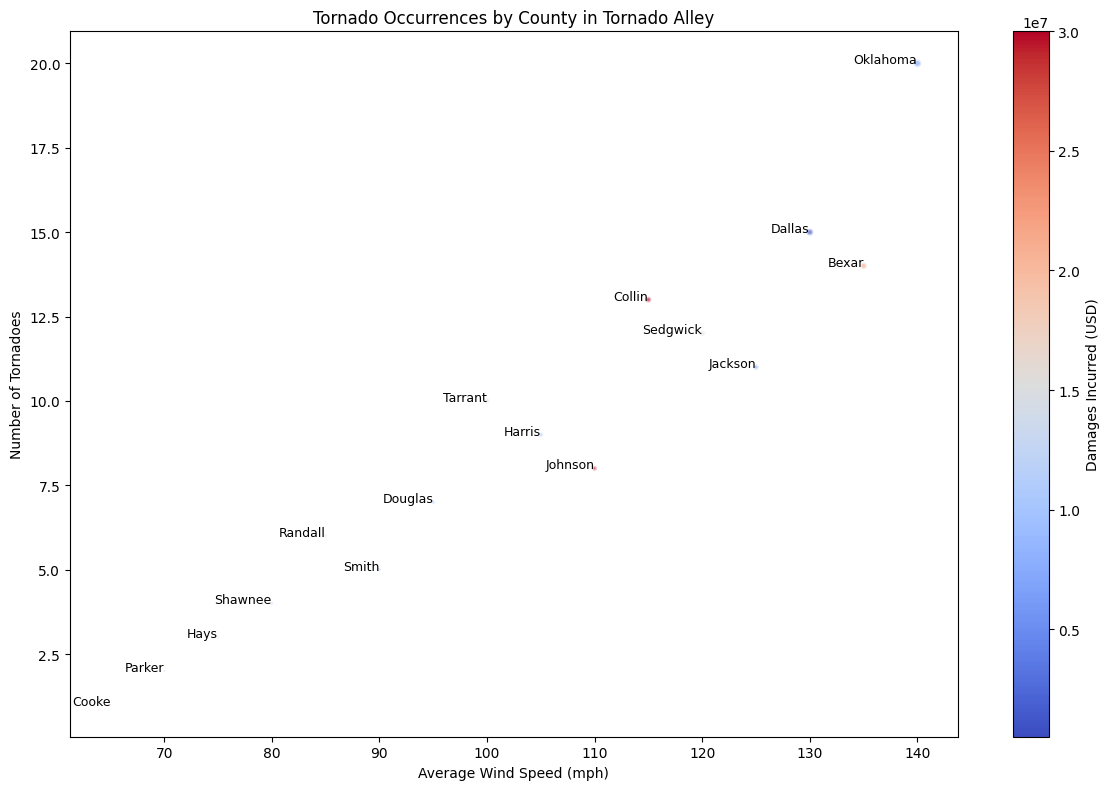What county had the highest number of tornadoes and what was the average wind speed for that county? First, identify the county with the highest number of tornadoes, which is Oklahoma with 20 tornadoes. Next, look at the average wind speed for Oklahoma, which is 140 mph.
Answer: Oklahoma; 140 mph Which county incurred the least amount of damages and how many tornadoes were recorded there? Identify the county with the least amount of damages, which is Cooke with $500,000. Then note the number of tornadoes recorded in Cooke, which is 1.
Answer: Cooke; 1 How does the average wind speed in Tarrant compare to that in Sedgwick? Locate Tarrant and Sedgwick on the chart. Tarrant has an average wind speed of 100 mph and Sedgwick has 120 mph. Thus, Sedgwick has a higher average wind speed compared to Tarrant.
Answer: Sedgwick has a higher wind speed What is the total number of tornadoes recorded in counties with an average wind speed of 100 mph or lower? Sum the number of tornadoes in Tarrant (10), Smith (5), Douglas (7), Randall (6), Shawnee (4), Hays (3), Parker (2), and Cooke (1) since their wind speeds are 100 mph or lower. The total is 10+5+7+6+4+3+2+1 = 38.
Answer: 38 Which county had a higher average wind speed, Johnson or Jackson, and what were their respective wind speeds? Identify Johnson (110 mph) and Jackson (125 mph) on the chart. Compare the wind speeds and find that Jackson has a higher wind speed.
Answer: Jackson; 125 mph What is the difference in damages incurred between Bexar and Dallas counties? Look at the damages for Bexar ($22,000,000) and Dallas ($25,000,000). Subtract the former from the latter to get $25,000,000 - $22,000,000 = $3,000,000.
Answer: $3,000,000 Which county has the smallest bubble size and what does this signify about the damages incurred there? The smallest bubble size belongs to Cooke, signifying it incurred the least damages at $500,000 based on the chart’s bubble size representation.
Answer: Cooke; $500,000 What is the average number of tornadoes for counties with wind speeds over 120 mph? Identify counties with wind speeds over 120 mph: Dallas (15), Oklahoma (20), Bexar (14), and Jackson (11). Average the number of tornadoes: (15 + 20 + 14 + 11) / 4 = 60 / 4 = 15.
Answer: 15 